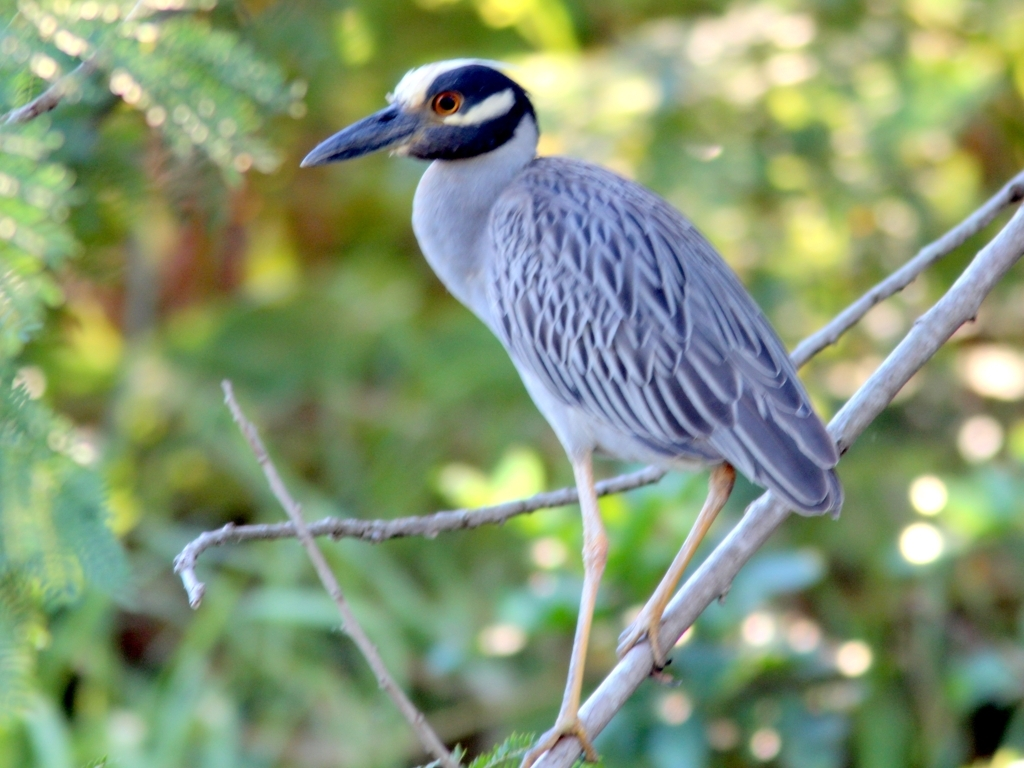What species of bird is this, and what could you tell me about its habitat? This appears to be a Yellow-crowned Night Heron. They are often found in wetlands, areas with lots of water like marshes or swamps, and they are known for their nocturnal feeding habits. How can you identify this bird as a Yellow-crowned Night Heron? The Yellow-crowned Night Heron can be identified by its bold black and white face pattern, grey body, and yellow crown feathers that can be seen when the bird is alert or during the breeding season. 